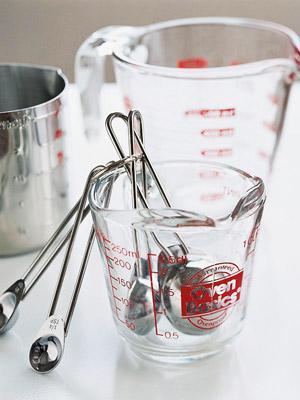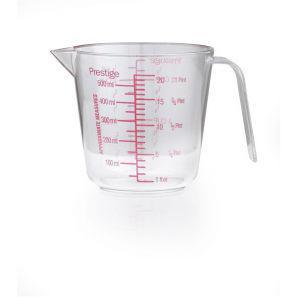The first image is the image on the left, the second image is the image on the right. For the images displayed, is the sentence "The left image shows a set of measuring spoons" factually correct? Answer yes or no. Yes. 